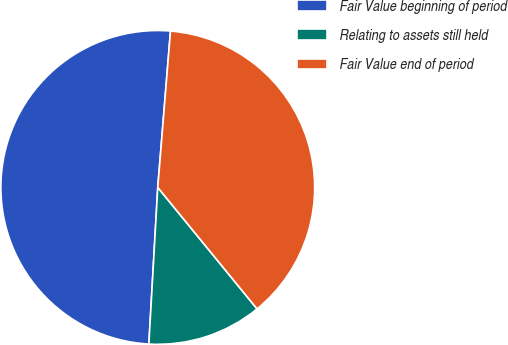<chart> <loc_0><loc_0><loc_500><loc_500><pie_chart><fcel>Fair Value beginning of period<fcel>Relating to assets still held<fcel>Fair Value end of period<nl><fcel>50.39%<fcel>11.81%<fcel>37.8%<nl></chart> 